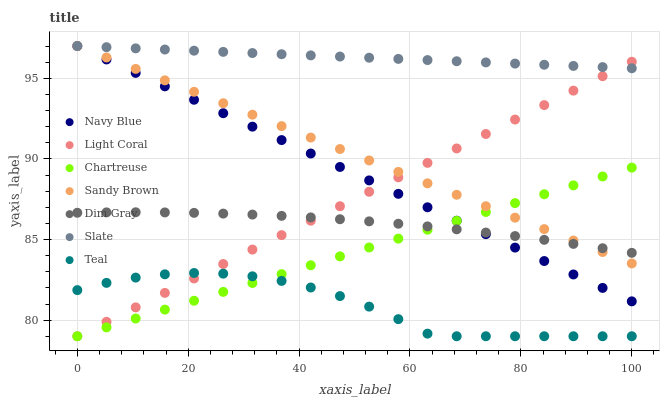Does Teal have the minimum area under the curve?
Answer yes or no. Yes. Does Slate have the maximum area under the curve?
Answer yes or no. Yes. Does Navy Blue have the minimum area under the curve?
Answer yes or no. No. Does Navy Blue have the maximum area under the curve?
Answer yes or no. No. Is Slate the smoothest?
Answer yes or no. Yes. Is Teal the roughest?
Answer yes or no. Yes. Is Navy Blue the smoothest?
Answer yes or no. No. Is Navy Blue the roughest?
Answer yes or no. No. Does Light Coral have the lowest value?
Answer yes or no. Yes. Does Navy Blue have the lowest value?
Answer yes or no. No. Does Sandy Brown have the highest value?
Answer yes or no. Yes. Does Light Coral have the highest value?
Answer yes or no. No. Is Teal less than Navy Blue?
Answer yes or no. Yes. Is Slate greater than Dim Gray?
Answer yes or no. Yes. Does Sandy Brown intersect Slate?
Answer yes or no. Yes. Is Sandy Brown less than Slate?
Answer yes or no. No. Is Sandy Brown greater than Slate?
Answer yes or no. No. Does Teal intersect Navy Blue?
Answer yes or no. No. 